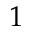<formula> <loc_0><loc_0><loc_500><loc_500>1</formula> 